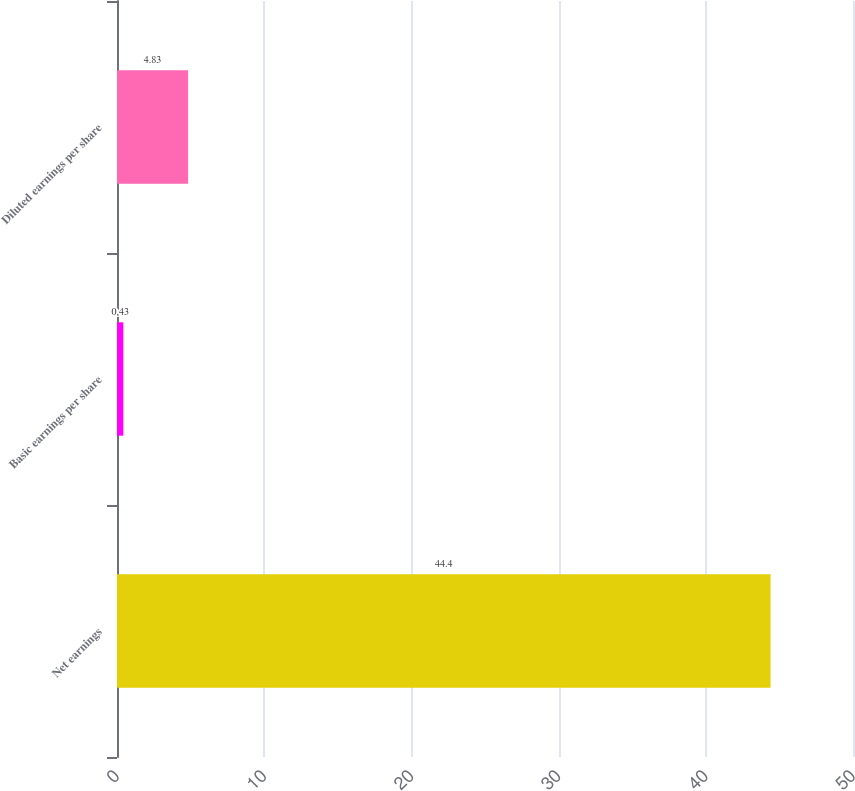<chart> <loc_0><loc_0><loc_500><loc_500><bar_chart><fcel>Net earnings<fcel>Basic earnings per share<fcel>Diluted earnings per share<nl><fcel>44.4<fcel>0.43<fcel>4.83<nl></chart> 